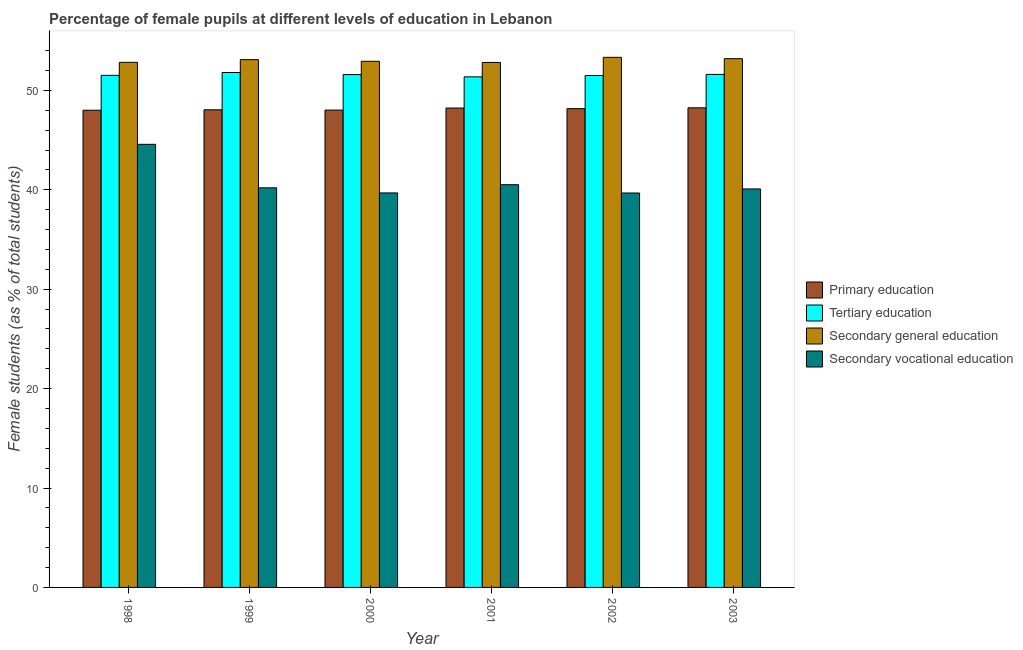Are the number of bars per tick equal to the number of legend labels?
Offer a very short reply. Yes. Are the number of bars on each tick of the X-axis equal?
Keep it short and to the point. Yes. What is the percentage of female students in tertiary education in 1998?
Keep it short and to the point. 51.51. Across all years, what is the maximum percentage of female students in secondary vocational education?
Ensure brevity in your answer.  44.57. Across all years, what is the minimum percentage of female students in primary education?
Offer a very short reply. 48. What is the total percentage of female students in secondary education in the graph?
Your answer should be very brief. 318.18. What is the difference between the percentage of female students in secondary education in 1999 and that in 2003?
Provide a succinct answer. -0.1. What is the difference between the percentage of female students in tertiary education in 1998 and the percentage of female students in secondary education in 1999?
Your answer should be compact. -0.29. What is the average percentage of female students in primary education per year?
Give a very brief answer. 48.12. In the year 2002, what is the difference between the percentage of female students in primary education and percentage of female students in secondary education?
Make the answer very short. 0. In how many years, is the percentage of female students in secondary education greater than 34 %?
Offer a terse response. 6. What is the ratio of the percentage of female students in secondary vocational education in 1999 to that in 2002?
Give a very brief answer. 1.01. Is the difference between the percentage of female students in secondary vocational education in 2000 and 2001 greater than the difference between the percentage of female students in secondary education in 2000 and 2001?
Offer a terse response. No. What is the difference between the highest and the second highest percentage of female students in tertiary education?
Give a very brief answer. 0.19. What is the difference between the highest and the lowest percentage of female students in primary education?
Give a very brief answer. 0.24. In how many years, is the percentage of female students in primary education greater than the average percentage of female students in primary education taken over all years?
Your answer should be very brief. 3. Is the sum of the percentage of female students in tertiary education in 1999 and 2002 greater than the maximum percentage of female students in primary education across all years?
Provide a succinct answer. Yes. What does the 2nd bar from the left in 2002 represents?
Keep it short and to the point. Tertiary education. What does the 4th bar from the right in 1998 represents?
Provide a succinct answer. Primary education. How many bars are there?
Your response must be concise. 24. Are all the bars in the graph horizontal?
Your answer should be compact. No. What is the difference between two consecutive major ticks on the Y-axis?
Provide a succinct answer. 10. Does the graph contain any zero values?
Offer a terse response. No. Does the graph contain grids?
Your answer should be very brief. No. Where does the legend appear in the graph?
Offer a very short reply. Center right. How many legend labels are there?
Your response must be concise. 4. What is the title of the graph?
Give a very brief answer. Percentage of female pupils at different levels of education in Lebanon. What is the label or title of the X-axis?
Keep it short and to the point. Year. What is the label or title of the Y-axis?
Your response must be concise. Female students (as % of total students). What is the Female students (as % of total students) of Primary education in 1998?
Provide a succinct answer. 48. What is the Female students (as % of total students) in Tertiary education in 1998?
Provide a short and direct response. 51.51. What is the Female students (as % of total students) in Secondary general education in 1998?
Offer a very short reply. 52.82. What is the Female students (as % of total students) in Secondary vocational education in 1998?
Ensure brevity in your answer.  44.57. What is the Female students (as % of total students) in Primary education in 1999?
Ensure brevity in your answer.  48.05. What is the Female students (as % of total students) of Tertiary education in 1999?
Your answer should be compact. 51.8. What is the Female students (as % of total students) of Secondary general education in 1999?
Your response must be concise. 53.09. What is the Female students (as % of total students) in Secondary vocational education in 1999?
Your answer should be compact. 40.2. What is the Female students (as % of total students) of Primary education in 2000?
Your answer should be very brief. 48.02. What is the Female students (as % of total students) in Tertiary education in 2000?
Provide a succinct answer. 51.59. What is the Female students (as % of total students) in Secondary general education in 2000?
Ensure brevity in your answer.  52.93. What is the Female students (as % of total students) of Secondary vocational education in 2000?
Your answer should be very brief. 39.69. What is the Female students (as % of total students) of Primary education in 2001?
Provide a succinct answer. 48.23. What is the Female students (as % of total students) in Tertiary education in 2001?
Give a very brief answer. 51.36. What is the Female students (as % of total students) of Secondary general education in 2001?
Make the answer very short. 52.81. What is the Female students (as % of total students) in Secondary vocational education in 2001?
Keep it short and to the point. 40.51. What is the Female students (as % of total students) in Primary education in 2002?
Offer a terse response. 48.17. What is the Female students (as % of total students) in Tertiary education in 2002?
Offer a very short reply. 51.5. What is the Female students (as % of total students) of Secondary general education in 2002?
Offer a very short reply. 53.33. What is the Female students (as % of total students) of Secondary vocational education in 2002?
Your response must be concise. 39.68. What is the Female students (as % of total students) of Primary education in 2003?
Give a very brief answer. 48.25. What is the Female students (as % of total students) of Tertiary education in 2003?
Offer a very short reply. 51.61. What is the Female students (as % of total students) in Secondary general education in 2003?
Offer a very short reply. 53.19. What is the Female students (as % of total students) of Secondary vocational education in 2003?
Your answer should be very brief. 40.09. Across all years, what is the maximum Female students (as % of total students) of Primary education?
Ensure brevity in your answer.  48.25. Across all years, what is the maximum Female students (as % of total students) of Tertiary education?
Ensure brevity in your answer.  51.8. Across all years, what is the maximum Female students (as % of total students) of Secondary general education?
Ensure brevity in your answer.  53.33. Across all years, what is the maximum Female students (as % of total students) in Secondary vocational education?
Make the answer very short. 44.57. Across all years, what is the minimum Female students (as % of total students) in Primary education?
Give a very brief answer. 48. Across all years, what is the minimum Female students (as % of total students) of Tertiary education?
Your response must be concise. 51.36. Across all years, what is the minimum Female students (as % of total students) in Secondary general education?
Offer a very short reply. 52.81. Across all years, what is the minimum Female students (as % of total students) in Secondary vocational education?
Offer a very short reply. 39.68. What is the total Female students (as % of total students) of Primary education in the graph?
Provide a short and direct response. 288.71. What is the total Female students (as % of total students) of Tertiary education in the graph?
Provide a succinct answer. 309.38. What is the total Female students (as % of total students) in Secondary general education in the graph?
Ensure brevity in your answer.  318.18. What is the total Female students (as % of total students) of Secondary vocational education in the graph?
Make the answer very short. 244.74. What is the difference between the Female students (as % of total students) in Primary education in 1998 and that in 1999?
Give a very brief answer. -0.04. What is the difference between the Female students (as % of total students) in Tertiary education in 1998 and that in 1999?
Keep it short and to the point. -0.29. What is the difference between the Female students (as % of total students) in Secondary general education in 1998 and that in 1999?
Offer a very short reply. -0.27. What is the difference between the Female students (as % of total students) in Secondary vocational education in 1998 and that in 1999?
Provide a short and direct response. 4.37. What is the difference between the Female students (as % of total students) of Primary education in 1998 and that in 2000?
Make the answer very short. -0.01. What is the difference between the Female students (as % of total students) in Tertiary education in 1998 and that in 2000?
Provide a short and direct response. -0.08. What is the difference between the Female students (as % of total students) of Secondary general education in 1998 and that in 2000?
Provide a short and direct response. -0.11. What is the difference between the Female students (as % of total students) of Secondary vocational education in 1998 and that in 2000?
Provide a succinct answer. 4.89. What is the difference between the Female students (as % of total students) in Primary education in 1998 and that in 2001?
Your response must be concise. -0.22. What is the difference between the Female students (as % of total students) of Tertiary education in 1998 and that in 2001?
Offer a very short reply. 0.15. What is the difference between the Female students (as % of total students) of Secondary general education in 1998 and that in 2001?
Provide a succinct answer. 0.01. What is the difference between the Female students (as % of total students) of Secondary vocational education in 1998 and that in 2001?
Your response must be concise. 4.06. What is the difference between the Female students (as % of total students) in Primary education in 1998 and that in 2002?
Provide a short and direct response. -0.16. What is the difference between the Female students (as % of total students) in Tertiary education in 1998 and that in 2002?
Ensure brevity in your answer.  0.01. What is the difference between the Female students (as % of total students) of Secondary general education in 1998 and that in 2002?
Make the answer very short. -0.5. What is the difference between the Female students (as % of total students) of Secondary vocational education in 1998 and that in 2002?
Your answer should be compact. 4.9. What is the difference between the Female students (as % of total students) of Primary education in 1998 and that in 2003?
Keep it short and to the point. -0.24. What is the difference between the Female students (as % of total students) of Tertiary education in 1998 and that in 2003?
Keep it short and to the point. -0.1. What is the difference between the Female students (as % of total students) of Secondary general education in 1998 and that in 2003?
Offer a very short reply. -0.37. What is the difference between the Female students (as % of total students) in Secondary vocational education in 1998 and that in 2003?
Offer a terse response. 4.49. What is the difference between the Female students (as % of total students) of Primary education in 1999 and that in 2000?
Your response must be concise. 0.03. What is the difference between the Female students (as % of total students) of Tertiary education in 1999 and that in 2000?
Make the answer very short. 0.21. What is the difference between the Female students (as % of total students) in Secondary general education in 1999 and that in 2000?
Provide a short and direct response. 0.17. What is the difference between the Female students (as % of total students) of Secondary vocational education in 1999 and that in 2000?
Your answer should be very brief. 0.52. What is the difference between the Female students (as % of total students) of Primary education in 1999 and that in 2001?
Keep it short and to the point. -0.18. What is the difference between the Female students (as % of total students) in Tertiary education in 1999 and that in 2001?
Provide a short and direct response. 0.44. What is the difference between the Female students (as % of total students) of Secondary general education in 1999 and that in 2001?
Offer a very short reply. 0.28. What is the difference between the Female students (as % of total students) in Secondary vocational education in 1999 and that in 2001?
Ensure brevity in your answer.  -0.31. What is the difference between the Female students (as % of total students) of Primary education in 1999 and that in 2002?
Your response must be concise. -0.12. What is the difference between the Female students (as % of total students) of Tertiary education in 1999 and that in 2002?
Ensure brevity in your answer.  0.3. What is the difference between the Female students (as % of total students) in Secondary general education in 1999 and that in 2002?
Keep it short and to the point. -0.23. What is the difference between the Female students (as % of total students) of Secondary vocational education in 1999 and that in 2002?
Provide a succinct answer. 0.52. What is the difference between the Female students (as % of total students) of Primary education in 1999 and that in 2003?
Give a very brief answer. -0.2. What is the difference between the Female students (as % of total students) in Tertiary education in 1999 and that in 2003?
Ensure brevity in your answer.  0.19. What is the difference between the Female students (as % of total students) of Secondary general education in 1999 and that in 2003?
Give a very brief answer. -0.1. What is the difference between the Female students (as % of total students) of Secondary vocational education in 1999 and that in 2003?
Your response must be concise. 0.11. What is the difference between the Female students (as % of total students) in Primary education in 2000 and that in 2001?
Offer a terse response. -0.21. What is the difference between the Female students (as % of total students) of Tertiary education in 2000 and that in 2001?
Your answer should be very brief. 0.23. What is the difference between the Female students (as % of total students) of Secondary general education in 2000 and that in 2001?
Ensure brevity in your answer.  0.12. What is the difference between the Female students (as % of total students) in Secondary vocational education in 2000 and that in 2001?
Your answer should be very brief. -0.83. What is the difference between the Female students (as % of total students) in Primary education in 2000 and that in 2002?
Provide a succinct answer. -0.15. What is the difference between the Female students (as % of total students) of Tertiary education in 2000 and that in 2002?
Offer a terse response. 0.09. What is the difference between the Female students (as % of total students) of Secondary general education in 2000 and that in 2002?
Provide a succinct answer. -0.4. What is the difference between the Female students (as % of total students) of Secondary vocational education in 2000 and that in 2002?
Offer a terse response. 0.01. What is the difference between the Female students (as % of total students) of Primary education in 2000 and that in 2003?
Ensure brevity in your answer.  -0.23. What is the difference between the Female students (as % of total students) of Tertiary education in 2000 and that in 2003?
Your answer should be compact. -0.02. What is the difference between the Female students (as % of total students) in Secondary general education in 2000 and that in 2003?
Offer a terse response. -0.27. What is the difference between the Female students (as % of total students) of Secondary vocational education in 2000 and that in 2003?
Ensure brevity in your answer.  -0.4. What is the difference between the Female students (as % of total students) of Primary education in 2001 and that in 2002?
Ensure brevity in your answer.  0.06. What is the difference between the Female students (as % of total students) of Tertiary education in 2001 and that in 2002?
Make the answer very short. -0.14. What is the difference between the Female students (as % of total students) in Secondary general education in 2001 and that in 2002?
Your answer should be very brief. -0.51. What is the difference between the Female students (as % of total students) in Secondary vocational education in 2001 and that in 2002?
Provide a short and direct response. 0.84. What is the difference between the Female students (as % of total students) in Primary education in 2001 and that in 2003?
Your answer should be compact. -0.02. What is the difference between the Female students (as % of total students) in Tertiary education in 2001 and that in 2003?
Provide a short and direct response. -0.25. What is the difference between the Female students (as % of total students) in Secondary general education in 2001 and that in 2003?
Your answer should be very brief. -0.38. What is the difference between the Female students (as % of total students) of Secondary vocational education in 2001 and that in 2003?
Provide a short and direct response. 0.43. What is the difference between the Female students (as % of total students) in Primary education in 2002 and that in 2003?
Provide a short and direct response. -0.08. What is the difference between the Female students (as % of total students) in Tertiary education in 2002 and that in 2003?
Keep it short and to the point. -0.11. What is the difference between the Female students (as % of total students) of Secondary general education in 2002 and that in 2003?
Offer a very short reply. 0.13. What is the difference between the Female students (as % of total students) in Secondary vocational education in 2002 and that in 2003?
Keep it short and to the point. -0.41. What is the difference between the Female students (as % of total students) in Primary education in 1998 and the Female students (as % of total students) in Tertiary education in 1999?
Keep it short and to the point. -3.79. What is the difference between the Female students (as % of total students) in Primary education in 1998 and the Female students (as % of total students) in Secondary general education in 1999?
Your answer should be compact. -5.09. What is the difference between the Female students (as % of total students) in Primary education in 1998 and the Female students (as % of total students) in Secondary vocational education in 1999?
Make the answer very short. 7.8. What is the difference between the Female students (as % of total students) in Tertiary education in 1998 and the Female students (as % of total students) in Secondary general education in 1999?
Provide a succinct answer. -1.58. What is the difference between the Female students (as % of total students) in Tertiary education in 1998 and the Female students (as % of total students) in Secondary vocational education in 1999?
Ensure brevity in your answer.  11.31. What is the difference between the Female students (as % of total students) in Secondary general education in 1998 and the Female students (as % of total students) in Secondary vocational education in 1999?
Provide a short and direct response. 12.62. What is the difference between the Female students (as % of total students) of Primary education in 1998 and the Female students (as % of total students) of Tertiary education in 2000?
Ensure brevity in your answer.  -3.59. What is the difference between the Female students (as % of total students) in Primary education in 1998 and the Female students (as % of total students) in Secondary general education in 2000?
Provide a succinct answer. -4.92. What is the difference between the Female students (as % of total students) in Primary education in 1998 and the Female students (as % of total students) in Secondary vocational education in 2000?
Offer a very short reply. 8.32. What is the difference between the Female students (as % of total students) in Tertiary education in 1998 and the Female students (as % of total students) in Secondary general education in 2000?
Give a very brief answer. -1.41. What is the difference between the Female students (as % of total students) of Tertiary education in 1998 and the Female students (as % of total students) of Secondary vocational education in 2000?
Offer a very short reply. 11.83. What is the difference between the Female students (as % of total students) in Secondary general education in 1998 and the Female students (as % of total students) in Secondary vocational education in 2000?
Offer a terse response. 13.14. What is the difference between the Female students (as % of total students) in Primary education in 1998 and the Female students (as % of total students) in Tertiary education in 2001?
Your answer should be very brief. -3.36. What is the difference between the Female students (as % of total students) of Primary education in 1998 and the Female students (as % of total students) of Secondary general education in 2001?
Provide a short and direct response. -4.81. What is the difference between the Female students (as % of total students) in Primary education in 1998 and the Female students (as % of total students) in Secondary vocational education in 2001?
Your answer should be very brief. 7.49. What is the difference between the Female students (as % of total students) of Tertiary education in 1998 and the Female students (as % of total students) of Secondary general education in 2001?
Give a very brief answer. -1.3. What is the difference between the Female students (as % of total students) in Tertiary education in 1998 and the Female students (as % of total students) in Secondary vocational education in 2001?
Offer a very short reply. 11. What is the difference between the Female students (as % of total students) in Secondary general education in 1998 and the Female students (as % of total students) in Secondary vocational education in 2001?
Your answer should be very brief. 12.31. What is the difference between the Female students (as % of total students) in Primary education in 1998 and the Female students (as % of total students) in Tertiary education in 2002?
Ensure brevity in your answer.  -3.49. What is the difference between the Female students (as % of total students) in Primary education in 1998 and the Female students (as % of total students) in Secondary general education in 2002?
Give a very brief answer. -5.32. What is the difference between the Female students (as % of total students) of Primary education in 1998 and the Female students (as % of total students) of Secondary vocational education in 2002?
Make the answer very short. 8.33. What is the difference between the Female students (as % of total students) of Tertiary education in 1998 and the Female students (as % of total students) of Secondary general education in 2002?
Your response must be concise. -1.81. What is the difference between the Female students (as % of total students) of Tertiary education in 1998 and the Female students (as % of total students) of Secondary vocational education in 2002?
Your response must be concise. 11.84. What is the difference between the Female students (as % of total students) in Secondary general education in 1998 and the Female students (as % of total students) in Secondary vocational education in 2002?
Your answer should be very brief. 13.14. What is the difference between the Female students (as % of total students) of Primary education in 1998 and the Female students (as % of total students) of Tertiary education in 2003?
Offer a terse response. -3.6. What is the difference between the Female students (as % of total students) of Primary education in 1998 and the Female students (as % of total students) of Secondary general education in 2003?
Give a very brief answer. -5.19. What is the difference between the Female students (as % of total students) of Primary education in 1998 and the Female students (as % of total students) of Secondary vocational education in 2003?
Offer a terse response. 7.92. What is the difference between the Female students (as % of total students) in Tertiary education in 1998 and the Female students (as % of total students) in Secondary general education in 2003?
Make the answer very short. -1.68. What is the difference between the Female students (as % of total students) of Tertiary education in 1998 and the Female students (as % of total students) of Secondary vocational education in 2003?
Keep it short and to the point. 11.43. What is the difference between the Female students (as % of total students) of Secondary general education in 1998 and the Female students (as % of total students) of Secondary vocational education in 2003?
Offer a terse response. 12.74. What is the difference between the Female students (as % of total students) of Primary education in 1999 and the Female students (as % of total students) of Tertiary education in 2000?
Your response must be concise. -3.54. What is the difference between the Female students (as % of total students) of Primary education in 1999 and the Female students (as % of total students) of Secondary general education in 2000?
Provide a succinct answer. -4.88. What is the difference between the Female students (as % of total students) of Primary education in 1999 and the Female students (as % of total students) of Secondary vocational education in 2000?
Your answer should be very brief. 8.36. What is the difference between the Female students (as % of total students) of Tertiary education in 1999 and the Female students (as % of total students) of Secondary general education in 2000?
Keep it short and to the point. -1.13. What is the difference between the Female students (as % of total students) of Tertiary education in 1999 and the Female students (as % of total students) of Secondary vocational education in 2000?
Offer a very short reply. 12.11. What is the difference between the Female students (as % of total students) in Secondary general education in 1999 and the Female students (as % of total students) in Secondary vocational education in 2000?
Ensure brevity in your answer.  13.41. What is the difference between the Female students (as % of total students) of Primary education in 1999 and the Female students (as % of total students) of Tertiary education in 2001?
Offer a terse response. -3.32. What is the difference between the Female students (as % of total students) of Primary education in 1999 and the Female students (as % of total students) of Secondary general education in 2001?
Offer a terse response. -4.76. What is the difference between the Female students (as % of total students) in Primary education in 1999 and the Female students (as % of total students) in Secondary vocational education in 2001?
Give a very brief answer. 7.53. What is the difference between the Female students (as % of total students) of Tertiary education in 1999 and the Female students (as % of total students) of Secondary general education in 2001?
Make the answer very short. -1.01. What is the difference between the Female students (as % of total students) in Tertiary education in 1999 and the Female students (as % of total students) in Secondary vocational education in 2001?
Provide a short and direct response. 11.29. What is the difference between the Female students (as % of total students) of Secondary general education in 1999 and the Female students (as % of total students) of Secondary vocational education in 2001?
Provide a succinct answer. 12.58. What is the difference between the Female students (as % of total students) of Primary education in 1999 and the Female students (as % of total students) of Tertiary education in 2002?
Provide a succinct answer. -3.45. What is the difference between the Female students (as % of total students) of Primary education in 1999 and the Female students (as % of total students) of Secondary general education in 2002?
Your answer should be very brief. -5.28. What is the difference between the Female students (as % of total students) in Primary education in 1999 and the Female students (as % of total students) in Secondary vocational education in 2002?
Give a very brief answer. 8.37. What is the difference between the Female students (as % of total students) of Tertiary education in 1999 and the Female students (as % of total students) of Secondary general education in 2002?
Provide a short and direct response. -1.53. What is the difference between the Female students (as % of total students) in Tertiary education in 1999 and the Female students (as % of total students) in Secondary vocational education in 2002?
Provide a succinct answer. 12.12. What is the difference between the Female students (as % of total students) of Secondary general education in 1999 and the Female students (as % of total students) of Secondary vocational education in 2002?
Give a very brief answer. 13.42. What is the difference between the Female students (as % of total students) of Primary education in 1999 and the Female students (as % of total students) of Tertiary education in 2003?
Offer a very short reply. -3.56. What is the difference between the Female students (as % of total students) in Primary education in 1999 and the Female students (as % of total students) in Secondary general education in 2003?
Give a very brief answer. -5.15. What is the difference between the Female students (as % of total students) in Primary education in 1999 and the Female students (as % of total students) in Secondary vocational education in 2003?
Your answer should be very brief. 7.96. What is the difference between the Female students (as % of total students) of Tertiary education in 1999 and the Female students (as % of total students) of Secondary general education in 2003?
Offer a very short reply. -1.39. What is the difference between the Female students (as % of total students) in Tertiary education in 1999 and the Female students (as % of total students) in Secondary vocational education in 2003?
Offer a terse response. 11.71. What is the difference between the Female students (as % of total students) in Secondary general education in 1999 and the Female students (as % of total students) in Secondary vocational education in 2003?
Provide a succinct answer. 13.01. What is the difference between the Female students (as % of total students) in Primary education in 2000 and the Female students (as % of total students) in Tertiary education in 2001?
Provide a succinct answer. -3.34. What is the difference between the Female students (as % of total students) in Primary education in 2000 and the Female students (as % of total students) in Secondary general education in 2001?
Your response must be concise. -4.79. What is the difference between the Female students (as % of total students) of Primary education in 2000 and the Female students (as % of total students) of Secondary vocational education in 2001?
Provide a short and direct response. 7.5. What is the difference between the Female students (as % of total students) in Tertiary education in 2000 and the Female students (as % of total students) in Secondary general education in 2001?
Ensure brevity in your answer.  -1.22. What is the difference between the Female students (as % of total students) of Tertiary education in 2000 and the Female students (as % of total students) of Secondary vocational education in 2001?
Give a very brief answer. 11.08. What is the difference between the Female students (as % of total students) in Secondary general education in 2000 and the Female students (as % of total students) in Secondary vocational education in 2001?
Provide a short and direct response. 12.41. What is the difference between the Female students (as % of total students) of Primary education in 2000 and the Female students (as % of total students) of Tertiary education in 2002?
Give a very brief answer. -3.48. What is the difference between the Female students (as % of total students) in Primary education in 2000 and the Female students (as % of total students) in Secondary general education in 2002?
Offer a very short reply. -5.31. What is the difference between the Female students (as % of total students) in Primary education in 2000 and the Female students (as % of total students) in Secondary vocational education in 2002?
Give a very brief answer. 8.34. What is the difference between the Female students (as % of total students) of Tertiary education in 2000 and the Female students (as % of total students) of Secondary general education in 2002?
Offer a terse response. -1.74. What is the difference between the Female students (as % of total students) of Tertiary education in 2000 and the Female students (as % of total students) of Secondary vocational education in 2002?
Your response must be concise. 11.91. What is the difference between the Female students (as % of total students) in Secondary general education in 2000 and the Female students (as % of total students) in Secondary vocational education in 2002?
Your answer should be very brief. 13.25. What is the difference between the Female students (as % of total students) in Primary education in 2000 and the Female students (as % of total students) in Tertiary education in 2003?
Your answer should be very brief. -3.59. What is the difference between the Female students (as % of total students) of Primary education in 2000 and the Female students (as % of total students) of Secondary general education in 2003?
Offer a terse response. -5.17. What is the difference between the Female students (as % of total students) in Primary education in 2000 and the Female students (as % of total students) in Secondary vocational education in 2003?
Ensure brevity in your answer.  7.93. What is the difference between the Female students (as % of total students) of Tertiary education in 2000 and the Female students (as % of total students) of Secondary general education in 2003?
Provide a succinct answer. -1.6. What is the difference between the Female students (as % of total students) in Tertiary education in 2000 and the Female students (as % of total students) in Secondary vocational education in 2003?
Provide a short and direct response. 11.5. What is the difference between the Female students (as % of total students) in Secondary general education in 2000 and the Female students (as % of total students) in Secondary vocational education in 2003?
Provide a short and direct response. 12.84. What is the difference between the Female students (as % of total students) in Primary education in 2001 and the Female students (as % of total students) in Tertiary education in 2002?
Ensure brevity in your answer.  -3.27. What is the difference between the Female students (as % of total students) in Primary education in 2001 and the Female students (as % of total students) in Secondary general education in 2002?
Offer a terse response. -5.1. What is the difference between the Female students (as % of total students) of Primary education in 2001 and the Female students (as % of total students) of Secondary vocational education in 2002?
Provide a short and direct response. 8.55. What is the difference between the Female students (as % of total students) in Tertiary education in 2001 and the Female students (as % of total students) in Secondary general education in 2002?
Ensure brevity in your answer.  -1.96. What is the difference between the Female students (as % of total students) in Tertiary education in 2001 and the Female students (as % of total students) in Secondary vocational education in 2002?
Make the answer very short. 11.68. What is the difference between the Female students (as % of total students) of Secondary general education in 2001 and the Female students (as % of total students) of Secondary vocational education in 2002?
Your response must be concise. 13.13. What is the difference between the Female students (as % of total students) of Primary education in 2001 and the Female students (as % of total students) of Tertiary education in 2003?
Your answer should be compact. -3.38. What is the difference between the Female students (as % of total students) of Primary education in 2001 and the Female students (as % of total students) of Secondary general education in 2003?
Make the answer very short. -4.97. What is the difference between the Female students (as % of total students) in Primary education in 2001 and the Female students (as % of total students) in Secondary vocational education in 2003?
Give a very brief answer. 8.14. What is the difference between the Female students (as % of total students) in Tertiary education in 2001 and the Female students (as % of total students) in Secondary general education in 2003?
Offer a terse response. -1.83. What is the difference between the Female students (as % of total students) of Tertiary education in 2001 and the Female students (as % of total students) of Secondary vocational education in 2003?
Provide a short and direct response. 11.28. What is the difference between the Female students (as % of total students) of Secondary general education in 2001 and the Female students (as % of total students) of Secondary vocational education in 2003?
Keep it short and to the point. 12.72. What is the difference between the Female students (as % of total students) of Primary education in 2002 and the Female students (as % of total students) of Tertiary education in 2003?
Keep it short and to the point. -3.44. What is the difference between the Female students (as % of total students) of Primary education in 2002 and the Female students (as % of total students) of Secondary general education in 2003?
Offer a terse response. -5.03. What is the difference between the Female students (as % of total students) in Primary education in 2002 and the Female students (as % of total students) in Secondary vocational education in 2003?
Give a very brief answer. 8.08. What is the difference between the Female students (as % of total students) in Tertiary education in 2002 and the Female students (as % of total students) in Secondary general education in 2003?
Offer a terse response. -1.69. What is the difference between the Female students (as % of total students) in Tertiary education in 2002 and the Female students (as % of total students) in Secondary vocational education in 2003?
Offer a terse response. 11.41. What is the difference between the Female students (as % of total students) in Secondary general education in 2002 and the Female students (as % of total students) in Secondary vocational education in 2003?
Give a very brief answer. 13.24. What is the average Female students (as % of total students) of Primary education per year?
Your answer should be very brief. 48.12. What is the average Female students (as % of total students) in Tertiary education per year?
Keep it short and to the point. 51.56. What is the average Female students (as % of total students) of Secondary general education per year?
Your answer should be very brief. 53.03. What is the average Female students (as % of total students) in Secondary vocational education per year?
Provide a succinct answer. 40.79. In the year 1998, what is the difference between the Female students (as % of total students) in Primary education and Female students (as % of total students) in Tertiary education?
Make the answer very short. -3.51. In the year 1998, what is the difference between the Female students (as % of total students) in Primary education and Female students (as % of total students) in Secondary general education?
Your answer should be very brief. -4.82. In the year 1998, what is the difference between the Female students (as % of total students) in Primary education and Female students (as % of total students) in Secondary vocational education?
Make the answer very short. 3.43. In the year 1998, what is the difference between the Female students (as % of total students) in Tertiary education and Female students (as % of total students) in Secondary general education?
Your answer should be very brief. -1.31. In the year 1998, what is the difference between the Female students (as % of total students) of Tertiary education and Female students (as % of total students) of Secondary vocational education?
Provide a succinct answer. 6.94. In the year 1998, what is the difference between the Female students (as % of total students) in Secondary general education and Female students (as % of total students) in Secondary vocational education?
Provide a short and direct response. 8.25. In the year 1999, what is the difference between the Female students (as % of total students) of Primary education and Female students (as % of total students) of Tertiary education?
Keep it short and to the point. -3.75. In the year 1999, what is the difference between the Female students (as % of total students) of Primary education and Female students (as % of total students) of Secondary general education?
Your response must be concise. -5.05. In the year 1999, what is the difference between the Female students (as % of total students) in Primary education and Female students (as % of total students) in Secondary vocational education?
Your answer should be very brief. 7.85. In the year 1999, what is the difference between the Female students (as % of total students) in Tertiary education and Female students (as % of total students) in Secondary general education?
Keep it short and to the point. -1.3. In the year 1999, what is the difference between the Female students (as % of total students) in Tertiary education and Female students (as % of total students) in Secondary vocational education?
Your answer should be compact. 11.6. In the year 1999, what is the difference between the Female students (as % of total students) in Secondary general education and Female students (as % of total students) in Secondary vocational education?
Your response must be concise. 12.89. In the year 2000, what is the difference between the Female students (as % of total students) of Primary education and Female students (as % of total students) of Tertiary education?
Your response must be concise. -3.57. In the year 2000, what is the difference between the Female students (as % of total students) of Primary education and Female students (as % of total students) of Secondary general education?
Offer a terse response. -4.91. In the year 2000, what is the difference between the Female students (as % of total students) of Primary education and Female students (as % of total students) of Secondary vocational education?
Provide a succinct answer. 8.33. In the year 2000, what is the difference between the Female students (as % of total students) in Tertiary education and Female students (as % of total students) in Secondary general education?
Give a very brief answer. -1.34. In the year 2000, what is the difference between the Female students (as % of total students) of Tertiary education and Female students (as % of total students) of Secondary vocational education?
Your answer should be very brief. 11.91. In the year 2000, what is the difference between the Female students (as % of total students) in Secondary general education and Female students (as % of total students) in Secondary vocational education?
Keep it short and to the point. 13.24. In the year 2001, what is the difference between the Female students (as % of total students) in Primary education and Female students (as % of total students) in Tertiary education?
Your answer should be very brief. -3.14. In the year 2001, what is the difference between the Female students (as % of total students) in Primary education and Female students (as % of total students) in Secondary general education?
Keep it short and to the point. -4.59. In the year 2001, what is the difference between the Female students (as % of total students) of Primary education and Female students (as % of total students) of Secondary vocational education?
Provide a short and direct response. 7.71. In the year 2001, what is the difference between the Female students (as % of total students) in Tertiary education and Female students (as % of total students) in Secondary general education?
Provide a succinct answer. -1.45. In the year 2001, what is the difference between the Female students (as % of total students) of Tertiary education and Female students (as % of total students) of Secondary vocational education?
Offer a very short reply. 10.85. In the year 2001, what is the difference between the Female students (as % of total students) of Secondary general education and Female students (as % of total students) of Secondary vocational education?
Ensure brevity in your answer.  12.3. In the year 2002, what is the difference between the Female students (as % of total students) of Primary education and Female students (as % of total students) of Tertiary education?
Ensure brevity in your answer.  -3.33. In the year 2002, what is the difference between the Female students (as % of total students) of Primary education and Female students (as % of total students) of Secondary general education?
Make the answer very short. -5.16. In the year 2002, what is the difference between the Female students (as % of total students) in Primary education and Female students (as % of total students) in Secondary vocational education?
Your answer should be compact. 8.49. In the year 2002, what is the difference between the Female students (as % of total students) in Tertiary education and Female students (as % of total students) in Secondary general education?
Offer a terse response. -1.83. In the year 2002, what is the difference between the Female students (as % of total students) in Tertiary education and Female students (as % of total students) in Secondary vocational education?
Your answer should be very brief. 11.82. In the year 2002, what is the difference between the Female students (as % of total students) of Secondary general education and Female students (as % of total students) of Secondary vocational education?
Make the answer very short. 13.65. In the year 2003, what is the difference between the Female students (as % of total students) in Primary education and Female students (as % of total students) in Tertiary education?
Provide a succinct answer. -3.36. In the year 2003, what is the difference between the Female students (as % of total students) of Primary education and Female students (as % of total students) of Secondary general education?
Provide a succinct answer. -4.95. In the year 2003, what is the difference between the Female students (as % of total students) in Primary education and Female students (as % of total students) in Secondary vocational education?
Provide a succinct answer. 8.16. In the year 2003, what is the difference between the Female students (as % of total students) in Tertiary education and Female students (as % of total students) in Secondary general education?
Provide a short and direct response. -1.58. In the year 2003, what is the difference between the Female students (as % of total students) of Tertiary education and Female students (as % of total students) of Secondary vocational education?
Your answer should be compact. 11.52. In the year 2003, what is the difference between the Female students (as % of total students) in Secondary general education and Female students (as % of total students) in Secondary vocational education?
Your response must be concise. 13.11. What is the ratio of the Female students (as % of total students) of Tertiary education in 1998 to that in 1999?
Provide a succinct answer. 0.99. What is the ratio of the Female students (as % of total students) in Secondary vocational education in 1998 to that in 1999?
Keep it short and to the point. 1.11. What is the ratio of the Female students (as % of total students) of Primary education in 1998 to that in 2000?
Keep it short and to the point. 1. What is the ratio of the Female students (as % of total students) in Secondary general education in 1998 to that in 2000?
Your answer should be very brief. 1. What is the ratio of the Female students (as % of total students) of Secondary vocational education in 1998 to that in 2000?
Provide a succinct answer. 1.12. What is the ratio of the Female students (as % of total students) in Tertiary education in 1998 to that in 2001?
Keep it short and to the point. 1. What is the ratio of the Female students (as % of total students) of Secondary general education in 1998 to that in 2001?
Your answer should be very brief. 1. What is the ratio of the Female students (as % of total students) of Secondary vocational education in 1998 to that in 2001?
Give a very brief answer. 1.1. What is the ratio of the Female students (as % of total students) in Secondary general education in 1998 to that in 2002?
Your answer should be compact. 0.99. What is the ratio of the Female students (as % of total students) of Secondary vocational education in 1998 to that in 2002?
Your answer should be compact. 1.12. What is the ratio of the Female students (as % of total students) in Primary education in 1998 to that in 2003?
Provide a succinct answer. 0.99. What is the ratio of the Female students (as % of total students) in Secondary general education in 1998 to that in 2003?
Keep it short and to the point. 0.99. What is the ratio of the Female students (as % of total students) in Secondary vocational education in 1998 to that in 2003?
Make the answer very short. 1.11. What is the ratio of the Female students (as % of total students) of Tertiary education in 1999 to that in 2000?
Your answer should be compact. 1. What is the ratio of the Female students (as % of total students) of Secondary general education in 1999 to that in 2000?
Ensure brevity in your answer.  1. What is the ratio of the Female students (as % of total students) in Secondary vocational education in 1999 to that in 2000?
Provide a short and direct response. 1.01. What is the ratio of the Female students (as % of total students) in Primary education in 1999 to that in 2001?
Make the answer very short. 1. What is the ratio of the Female students (as % of total students) of Tertiary education in 1999 to that in 2001?
Offer a terse response. 1.01. What is the ratio of the Female students (as % of total students) in Secondary general education in 1999 to that in 2001?
Your response must be concise. 1.01. What is the ratio of the Female students (as % of total students) of Primary education in 1999 to that in 2002?
Provide a short and direct response. 1. What is the ratio of the Female students (as % of total students) of Secondary vocational education in 1999 to that in 2002?
Make the answer very short. 1.01. What is the ratio of the Female students (as % of total students) of Primary education in 1999 to that in 2003?
Offer a terse response. 1. What is the ratio of the Female students (as % of total students) in Secondary vocational education in 2000 to that in 2001?
Ensure brevity in your answer.  0.98. What is the ratio of the Female students (as % of total students) in Primary education in 2000 to that in 2002?
Your answer should be very brief. 1. What is the ratio of the Female students (as % of total students) of Secondary general education in 2000 to that in 2002?
Offer a terse response. 0.99. What is the ratio of the Female students (as % of total students) in Primary education in 2000 to that in 2003?
Offer a terse response. 1. What is the ratio of the Female students (as % of total students) in Secondary general education in 2000 to that in 2003?
Offer a very short reply. 0.99. What is the ratio of the Female students (as % of total students) of Secondary vocational education in 2000 to that in 2003?
Provide a succinct answer. 0.99. What is the ratio of the Female students (as % of total students) in Primary education in 2001 to that in 2002?
Your answer should be very brief. 1. What is the ratio of the Female students (as % of total students) of Tertiary education in 2001 to that in 2002?
Ensure brevity in your answer.  1. What is the ratio of the Female students (as % of total students) in Secondary vocational education in 2001 to that in 2002?
Ensure brevity in your answer.  1.02. What is the ratio of the Female students (as % of total students) of Secondary general education in 2001 to that in 2003?
Provide a short and direct response. 0.99. What is the ratio of the Female students (as % of total students) of Secondary vocational education in 2001 to that in 2003?
Your answer should be compact. 1.01. What is the ratio of the Female students (as % of total students) of Tertiary education in 2002 to that in 2003?
Offer a very short reply. 1. What is the ratio of the Female students (as % of total students) in Secondary vocational education in 2002 to that in 2003?
Make the answer very short. 0.99. What is the difference between the highest and the second highest Female students (as % of total students) of Primary education?
Provide a succinct answer. 0.02. What is the difference between the highest and the second highest Female students (as % of total students) of Tertiary education?
Provide a succinct answer. 0.19. What is the difference between the highest and the second highest Female students (as % of total students) in Secondary general education?
Your answer should be very brief. 0.13. What is the difference between the highest and the second highest Female students (as % of total students) in Secondary vocational education?
Provide a succinct answer. 4.06. What is the difference between the highest and the lowest Female students (as % of total students) of Primary education?
Your answer should be compact. 0.24. What is the difference between the highest and the lowest Female students (as % of total students) in Tertiary education?
Offer a very short reply. 0.44. What is the difference between the highest and the lowest Female students (as % of total students) of Secondary general education?
Offer a terse response. 0.51. What is the difference between the highest and the lowest Female students (as % of total students) of Secondary vocational education?
Your answer should be very brief. 4.9. 